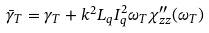Convert formula to latex. <formula><loc_0><loc_0><loc_500><loc_500>\bar { \gamma } _ { T } = \gamma _ { T } + k ^ { 2 } L _ { q } I _ { q } ^ { 2 } \omega _ { T } \chi _ { z z } ^ { \prime \prime } ( \omega _ { T } )</formula> 